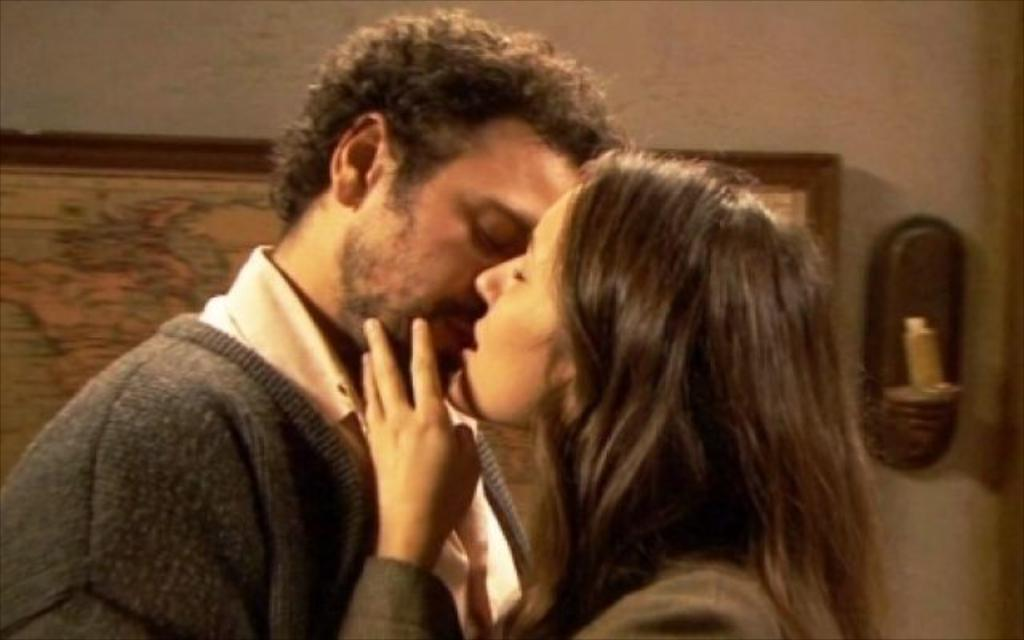Who is present in the image? There is a person and a girl in the image. What are the person and the girl doing in the image? The person and the girl are kissing each other in the image. What can be seen on the wall in the image? There is a frame hanging on the wall in the image. What is located beside the frame on the wall? There is an object beside the frame in the image. What is the purpose of the dime in the image? There is no dime present in the image. 